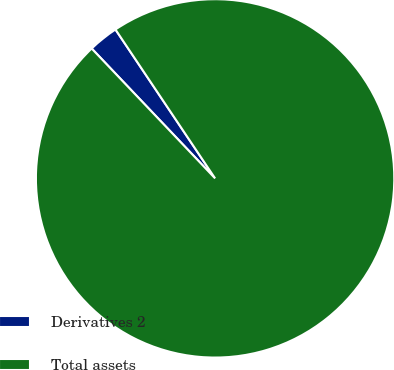Convert chart to OTSL. <chart><loc_0><loc_0><loc_500><loc_500><pie_chart><fcel>Derivatives 2<fcel>Total assets<nl><fcel>2.71%<fcel>97.29%<nl></chart> 